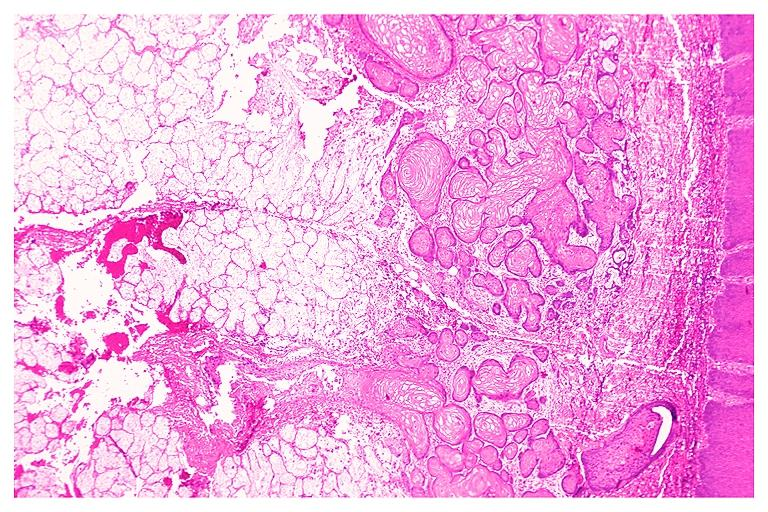does carcinomatosis show necrotizing sialometaplasia?
Answer the question using a single word or phrase. No 